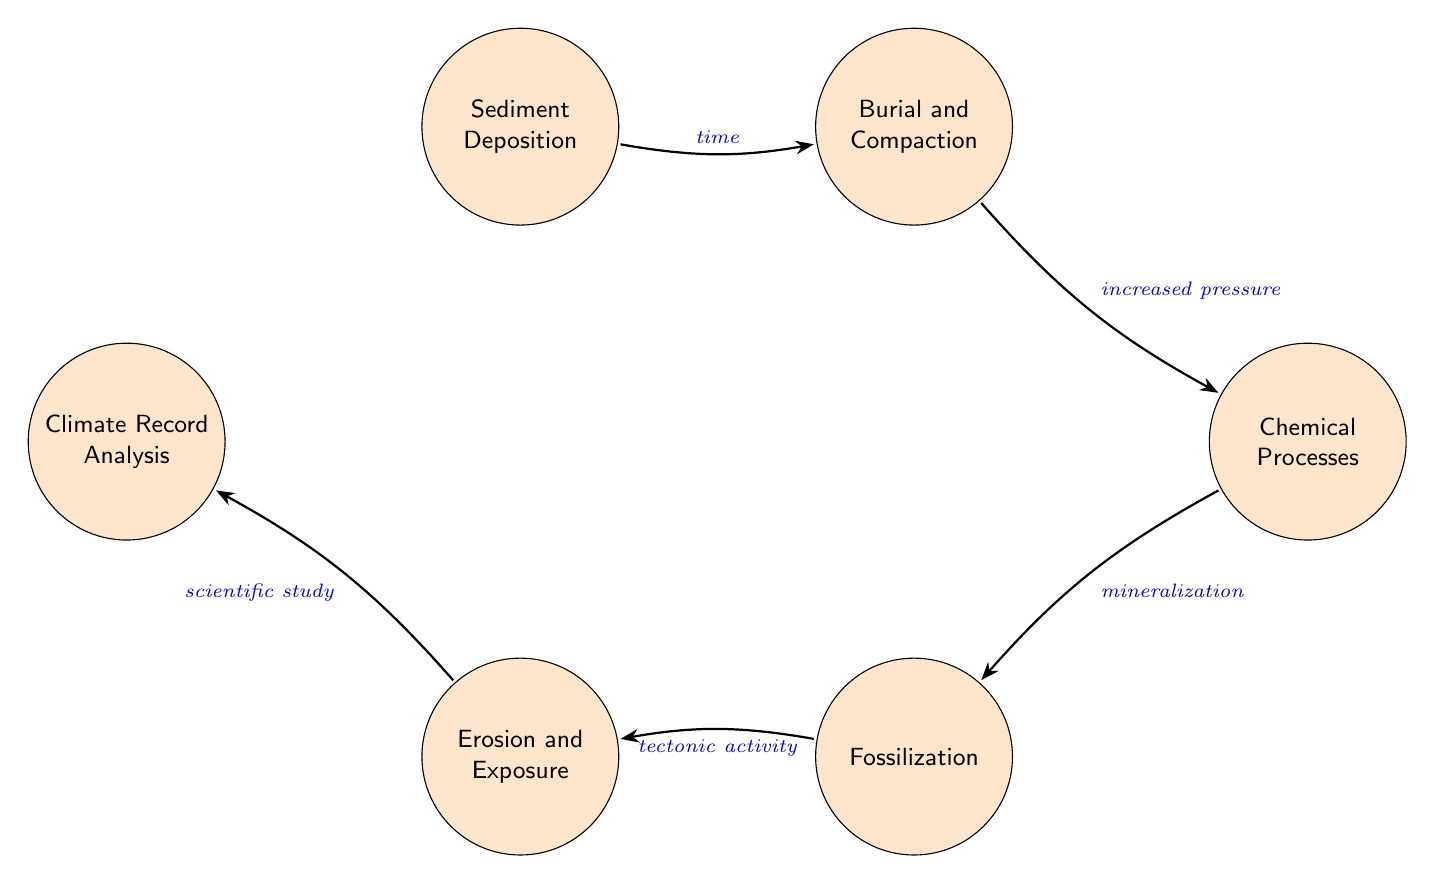What is the first state in the fossilization process? The first state in the diagram is "Sediment Deposition," which depicts the accumulation of sediments like sand, mud, and organic material in basins.
Answer: Sediment Deposition What is the trigger for moving from "Burial and Compaction" to "Chemical Processes"? The trigger for this transition is "increased pressure," which indicates that as sediments become buried, the pressure increases leading to the subsequent step of chemical changes.
Answer: increased pressure How many total states are represented in the diagram? The diagram features a total of six states: "Sediment Deposition," "Burial and Compaction," "Chemical Processes," "Fossilization," "Erosion and Exposure," and "Climate Record Analysis."
Answer: 6 What is the relationship between "Fossilization" and "Erosion and Exposure"? The relationship is established by the trigger "tectonic activity," which indicates that once the fossilization occurs, tectonic events can lead to the exposure of these fossils through processes such as erosion.
Answer: tectonic activity In which state is climate record analysis performed? The climate record analysis is performed in the state labeled "Climate Record Analysis," which is the final state indicating the study of fossilized remains to infer past climate conditions.
Answer: Climate Record Analysis What is the last state in the fossilization process? The last state in the diagram is "Climate Record Analysis," which represents the conclusion of the process where scientists study fossils and sediments to understand historical climate conditions.
Answer: Climate Record Analysis What are the triggers that lead to the "Fossilization" state? The only trigger that leads to "Fossilization" is "mineralization," which occurs when minerals start replacing organic material buried by sediments.
Answer: mineralization Which state follows "Erosion and Exposure"? The state that follows "Erosion and Exposure" is "Climate Record Analysis," indicating the final analysis phase that follows the exposure of fossils.
Answer: Climate Record Analysis 